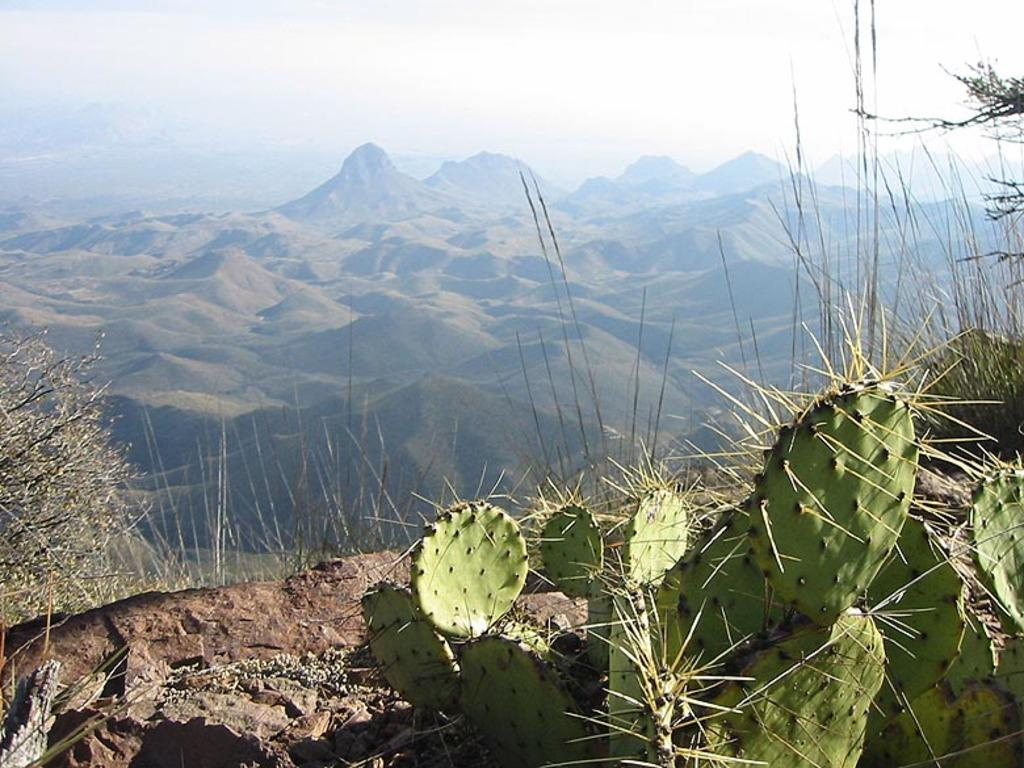What type of living organisms can be seen in the image? There are plants in the image. What color are the plants in the image? The plants are green. What can be seen in the background of the image? There are mountains and the sky visible in the background of the image. What is the color of the sky in the image? The sky is white in color. Can you tell me how many trees are talking to each other in the image? There are no trees present in the image, and trees cannot talk. 